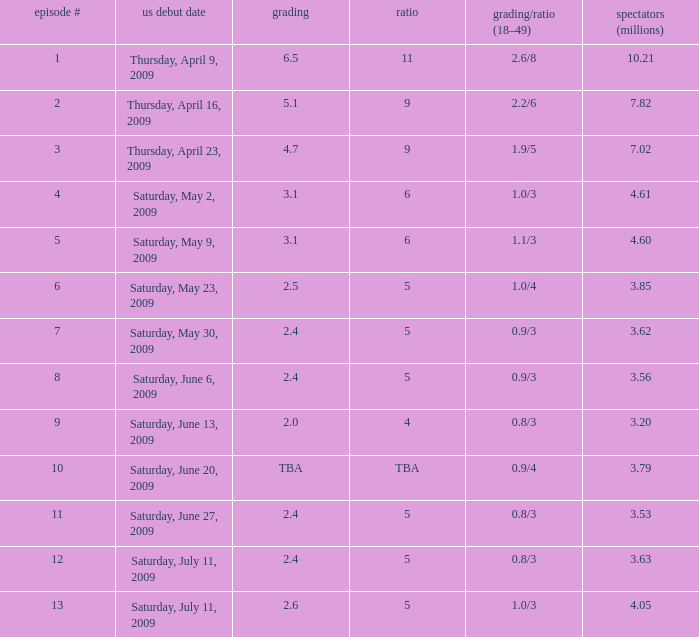What is the lowest numbered episode that had a rating/share of 0.9/4 and more than 3.79 million viewers? None. 